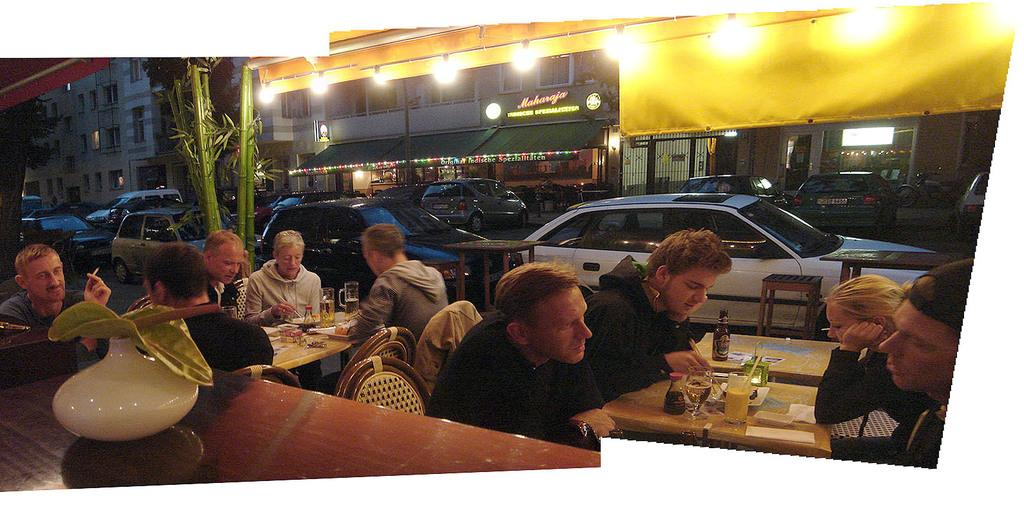What are the people in the image doing? The people are sitting around a table. What activity are the people engaged in while sitting at the table? The people are having food on the table. What can be seen in the background of the image? There is a car riding on the roads and a building in the background. What type of vegetation is visible in the background? There are big plants in the background. How does the shock affect the trail in the image? There is no shock or trail present in the image. 